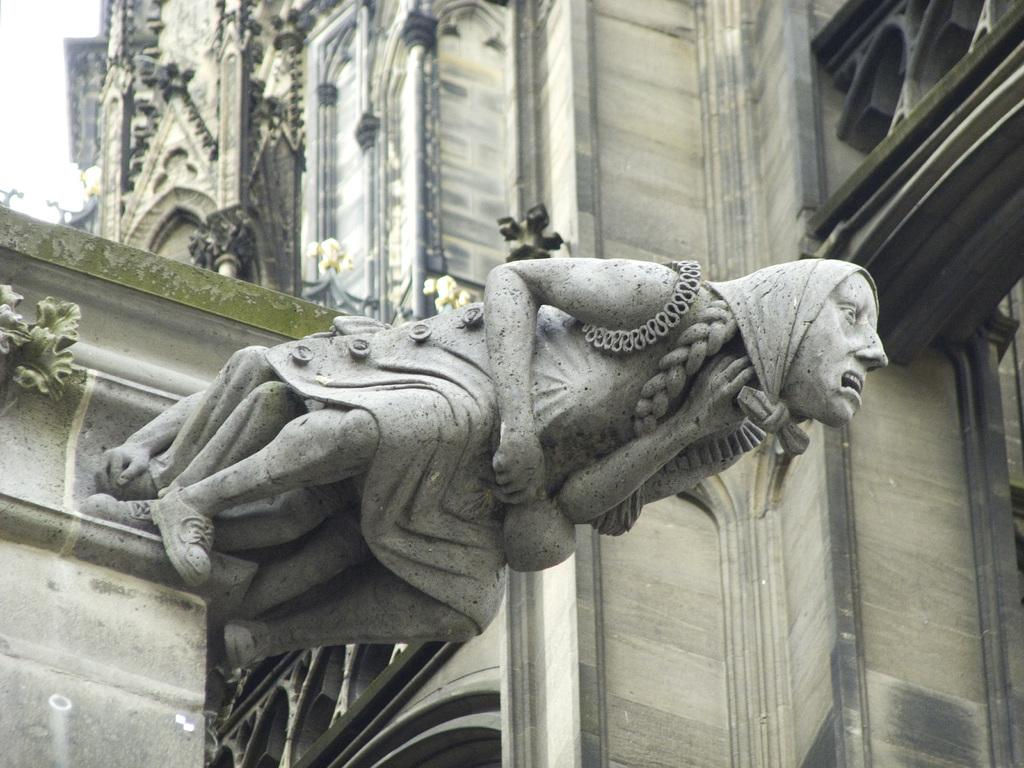What is the main subject in the middle of the image? There is an architecture in the middle of the image. What can be seen in the background of the image? There is a building and a steeple in the background of the image. What is visible in the sky in the image? The sky is visible in the background of the image. How does the liquid in the image affect the sheep's anger? There is no liquid or sheep present in the image, so this question cannot be answered. 